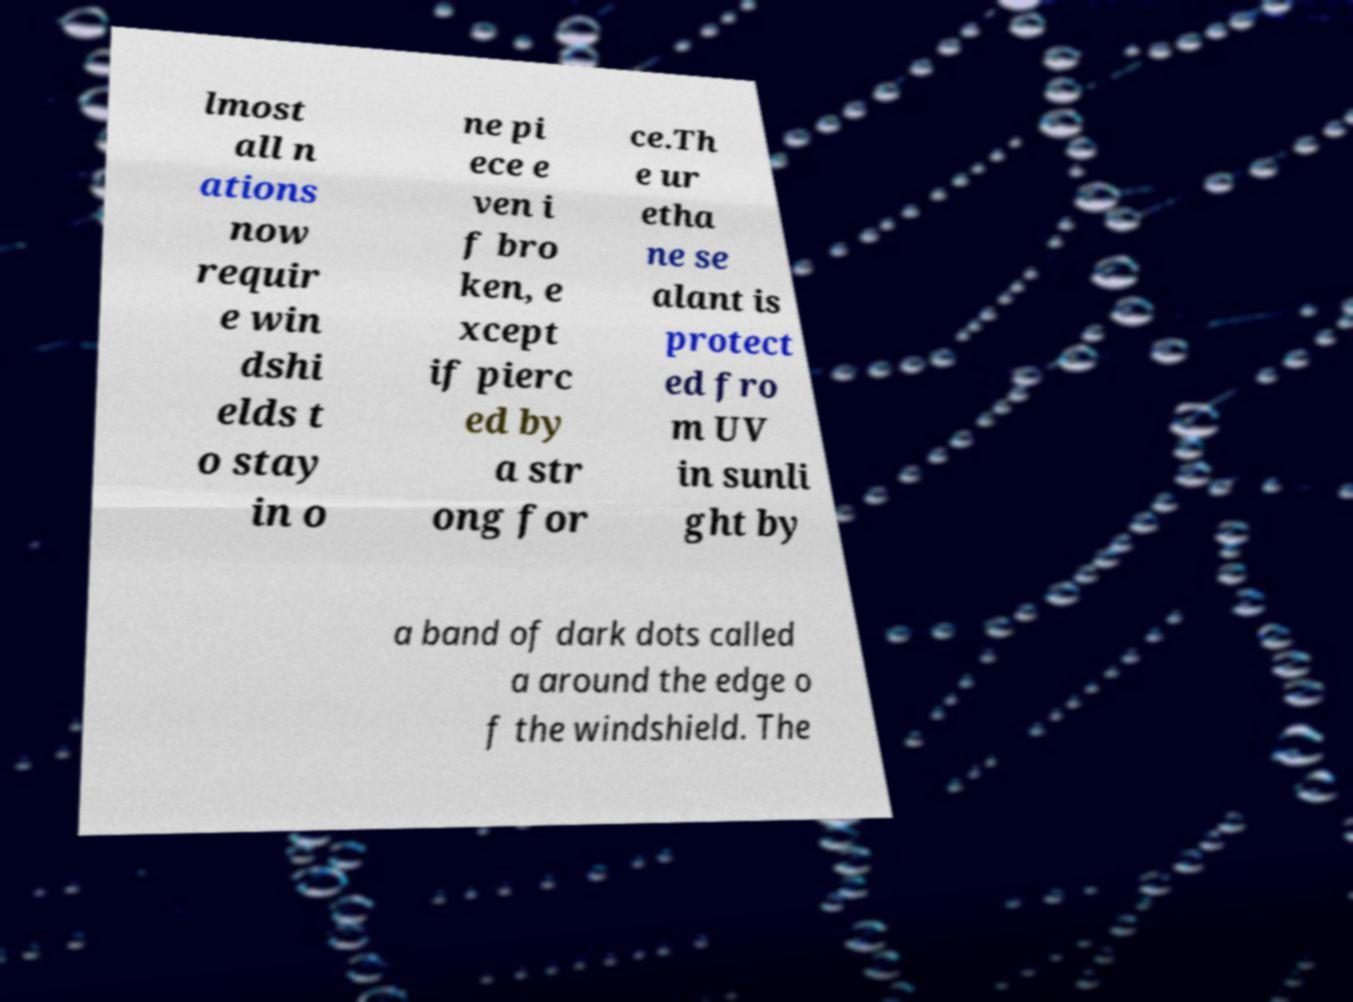Please identify and transcribe the text found in this image. lmost all n ations now requir e win dshi elds t o stay in o ne pi ece e ven i f bro ken, e xcept if pierc ed by a str ong for ce.Th e ur etha ne se alant is protect ed fro m UV in sunli ght by a band of dark dots called a around the edge o f the windshield. The 